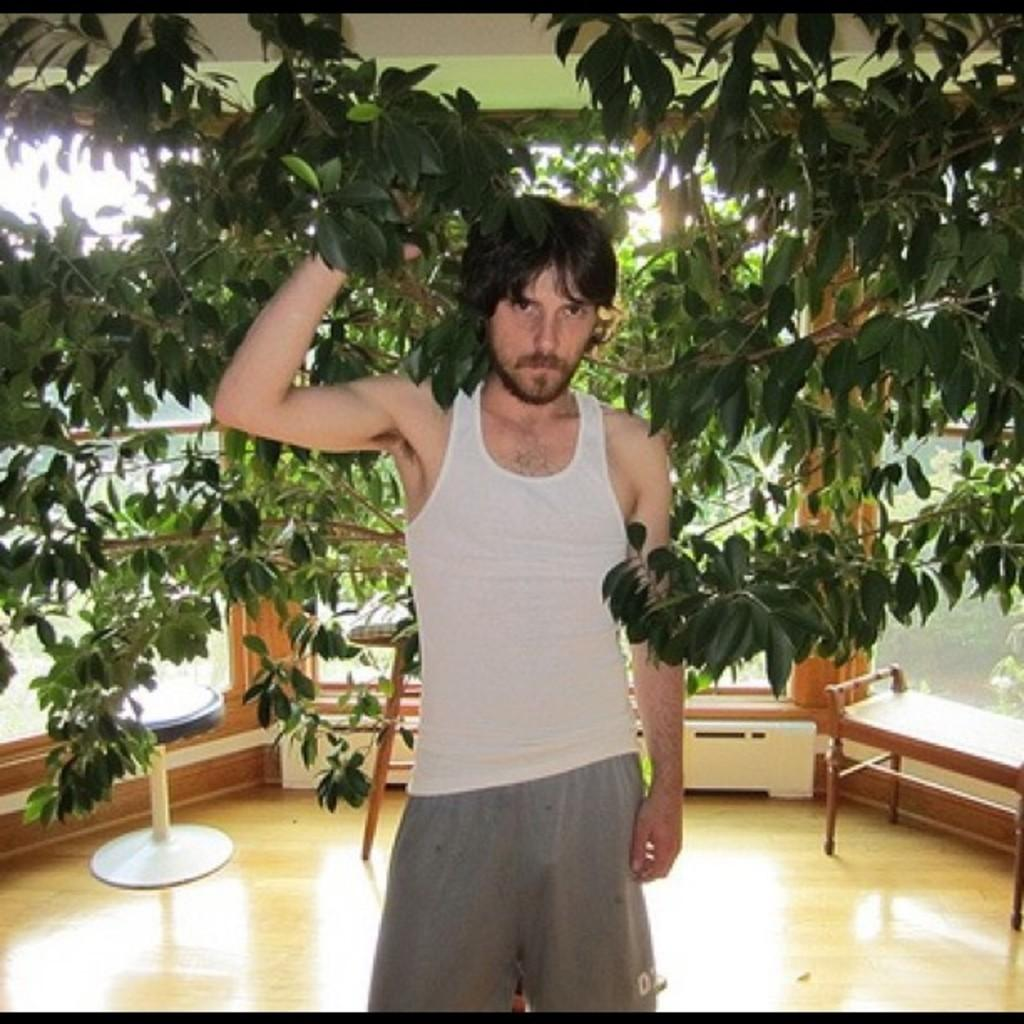What is the main subject of the image? There is a person standing in the image. What is the person holding in the image? The person is holding tree leaves. What furniture can be seen in the background of the image? There is a chair and a table in the background of the image. How many boys are sitting comfortably on the chair in the image? There are no boys present in the image, and the chair is in the background, not being used for sitting. 